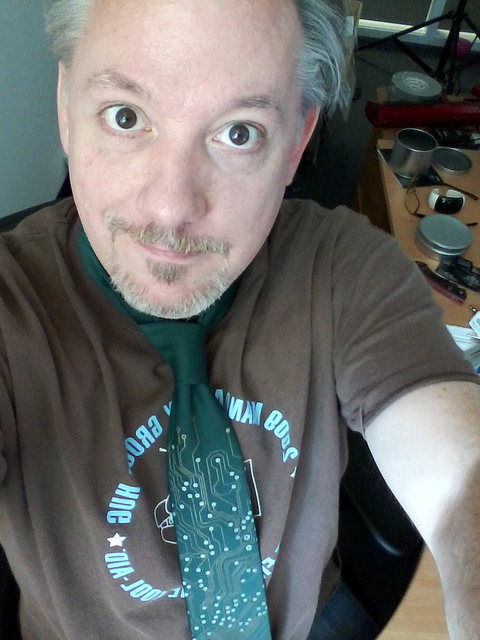Please transcribe the text information in this image. Hne BOOS DIA 